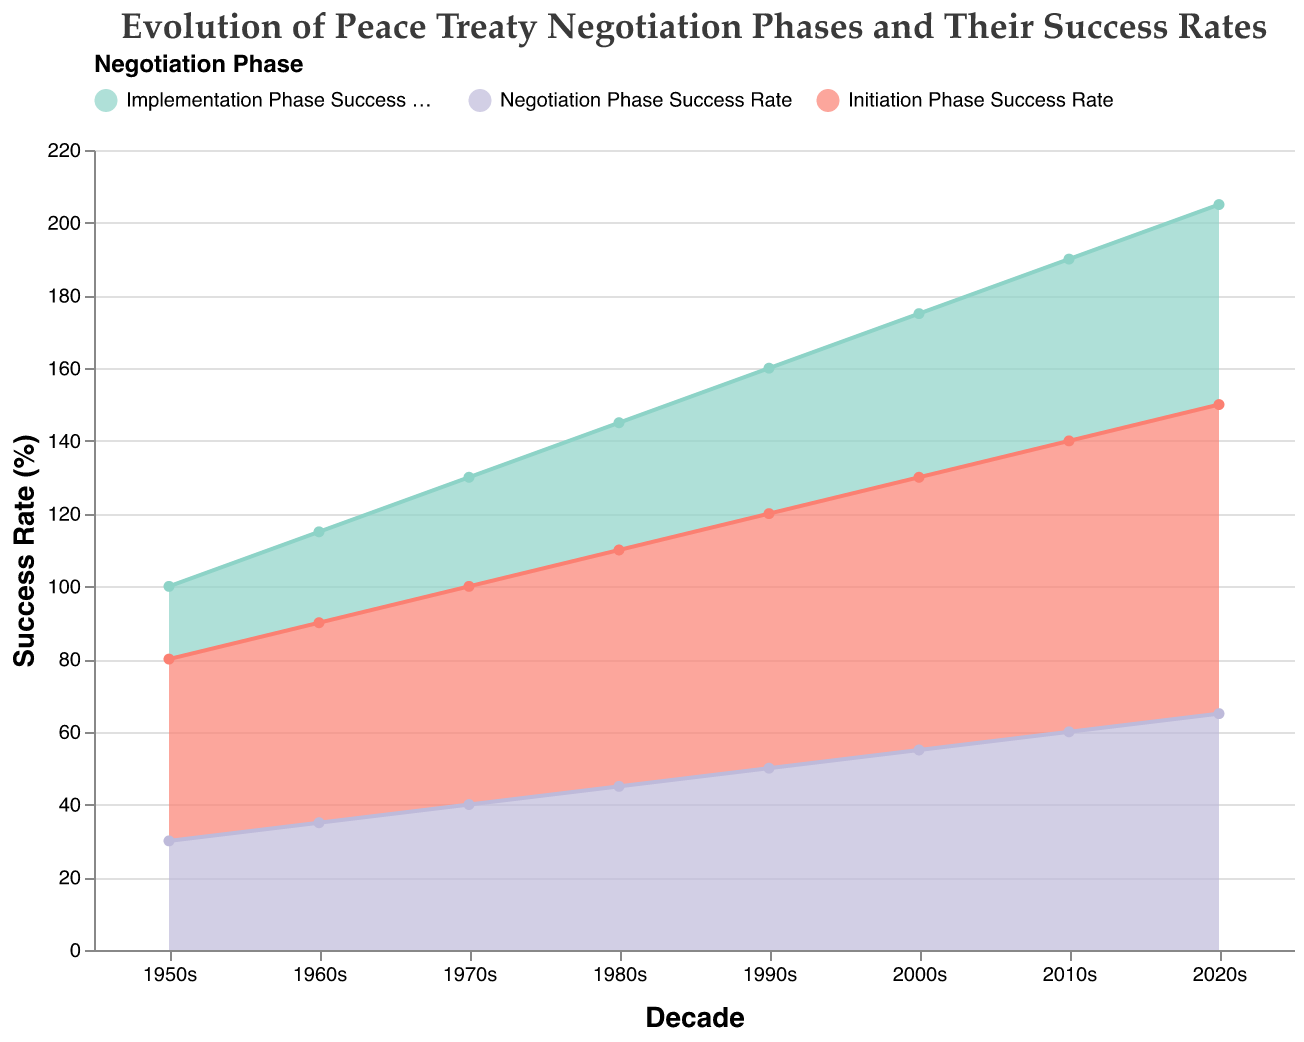What is the title of the chart? The title of the chart is at the top and reads, "Evolution of Peace Treaty Negotiation Phases and Their Success Rates".
Answer: Evolution of Peace Treaty Negotiation Phases and Their Success Rates Which decade has the highest Initiation Phase success rate? The highest Initiation Phase success rate can be found by looking at the chart's data points for each decade and identifying the maximum rate. The 2020s show the highest Initiation Phase success rate at 85%.
Answer: 2020s Compare the success rates of the Implementation Phase in the 1950s and 2020s. Which phase has the higher success rate? The Implementation Phase success rate is represented by the light green area. Comparing the visually distinct points in the 1950s and 2020s, the 1950s have a success rate of 20%, while the 2020s have a success rate of 55%. Therefore, the 2020s have the higher success rate.
Answer: 2020s What is the overall trend in the Negotiation Phase success rates from the 1950s to the 2020s? Observing the Negotiation Phase success rates, shown in purple, from the 1950s (30%) through to the 2020s (65%), there is a clear upward trend in the success rates over the decades, indicating an improvement.
Answer: Upward trend By how much did the Implementation Phase success rate increase from the 1960s to the 2010s? The Implementation Phase success rate in the 1960s was 25% and in the 2010s it was 50%. The increase can be calculated as 50 - 25, which equals an increase of 25 percentage points.
Answer: 25 percentage points Which Negotiation Phase success rate is higher: the 1970s or the 1990s, and by how much? The Negotiation Phase success rate in the 1970s was 40%, and in the 1990s, it was 50%. The rate in the 1990s is higher by 10 percentage points (50 - 40).
Answer: 1990s by 10 percentage points What are the three phases represented in the chart, and how are they color-coded? The chart represents three phases: Initiation Phase, Negotiation Phase, and Implementation Phase. The color codes are light coral for the Initiation Phase, purple for the Negotiation Phase, and light green for the Implementation Phase.
Answer: Initiation, Negotiation, Implementation; coral, purple, green What is the difference between the highest and lowest success rates of any phase within a single decade? First, identify the highest and lowest success rates within one decade:
  - 2020s: Initiation Phase (85%), Negotiation Phase (65%), Implementation Phase (55%).
  The maximum difference within the 2020s is 85-55 = 30.
Answer: 30 By the end of which decade did the Implementation Phase success rate first reach at least 35%? Track the Implementation Phase success rate per decade on the chart:
  - 1950s (20%), 1960s (25%), 1970s (30%), 1980s (35%).
  The threshold of 35% is reached by the end of the 1980s.
Answer: 1980s 